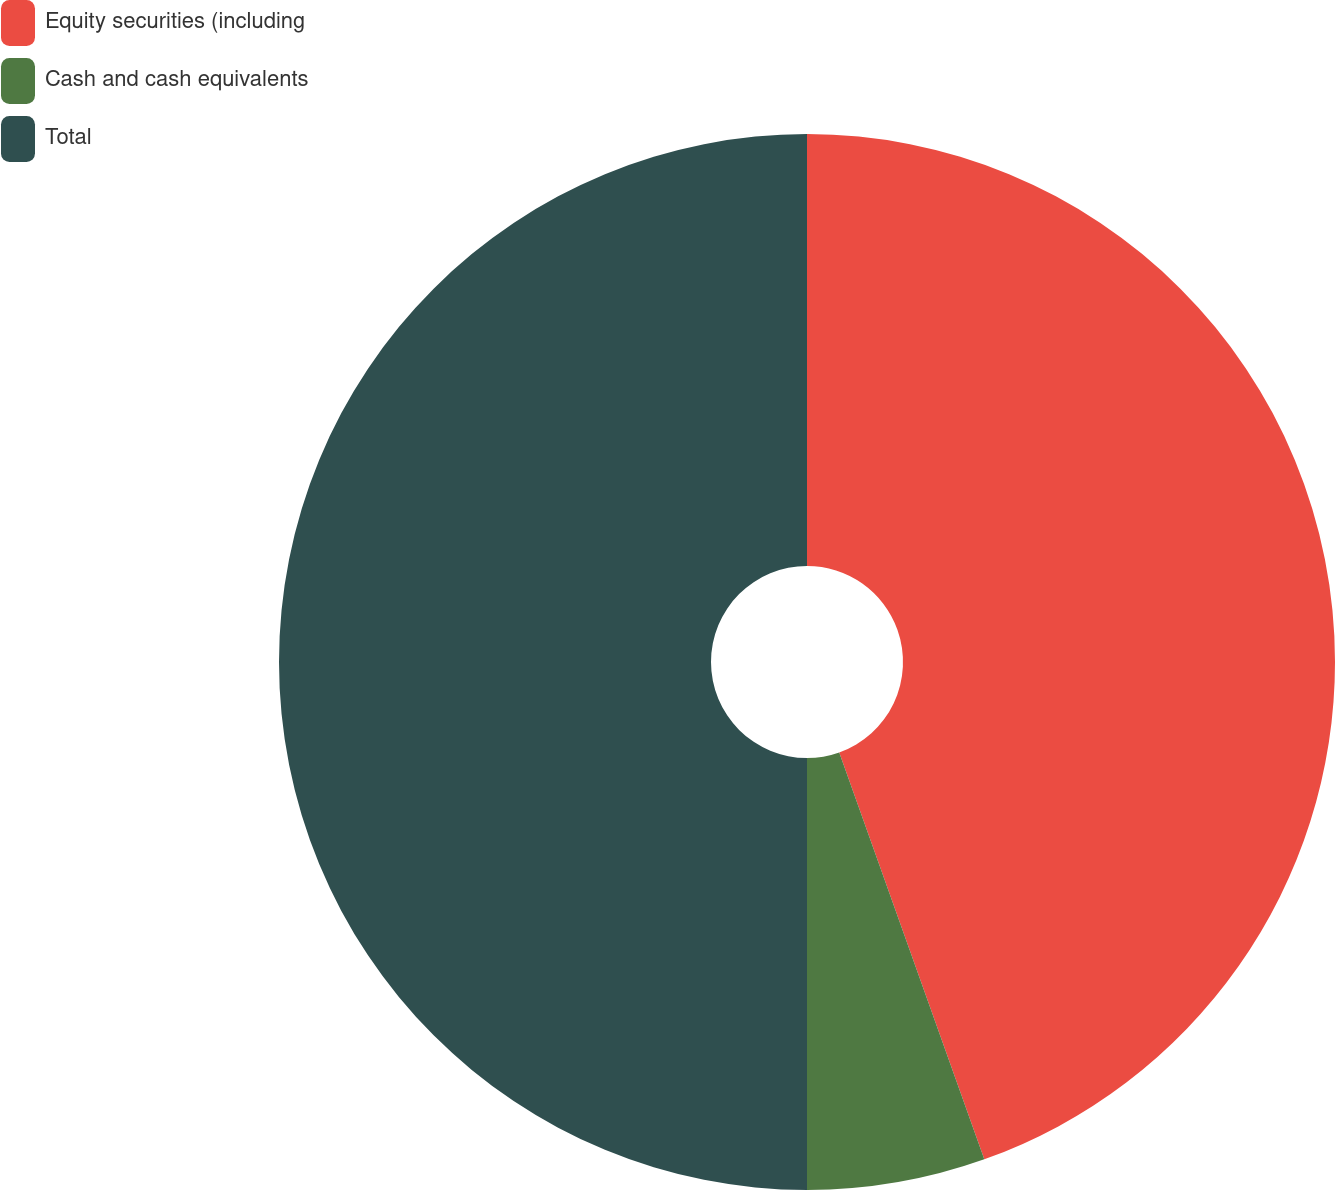Convert chart to OTSL. <chart><loc_0><loc_0><loc_500><loc_500><pie_chart><fcel>Equity securities (including<fcel>Cash and cash equivalents<fcel>Total<nl><fcel>44.55%<fcel>5.45%<fcel>50.0%<nl></chart> 